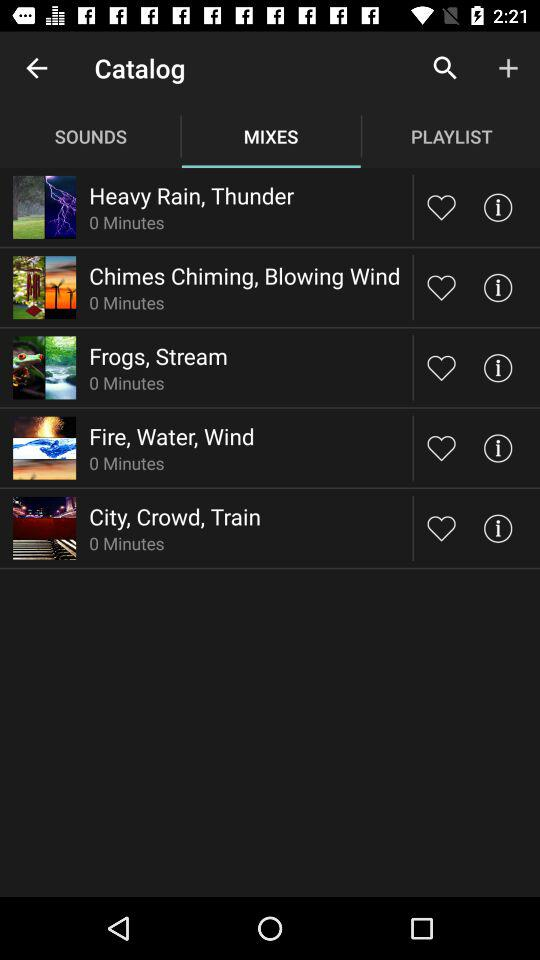What is the duration of "Heavy Rain, Thunder"? The duration is 0 minutes. 